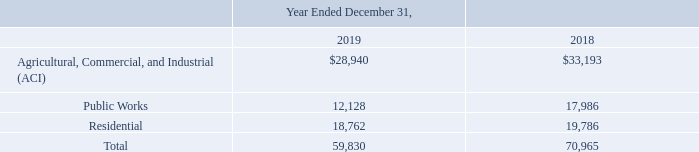3. REVENUE FROM CONTRACTS WITH CUSTOMERS
Revenues and related costs on construction contracts are recognized as the performance obligations are satisfied over time in accordance with ASC 606, Revenue from Contracts with Customers. Under ASC 606, revenue and associated profit, will be recognized as the customer obtains control of the goods and services promised in the contract (i.e., performance obligations). The cost of uninstalled materials or equipment will generally be excluded from the Company’s recognition of profit, unless specifically produced or manufactured for a project, because such costs are not considered to be a measure of progress.
The following table represents a disaggregation of revenue by customer type from contracts with customers for the years ended December 31, 2019 and 2018:
How are revenue and associated profit recognised under ASC 606? Recognized as the customer obtains control of the goods and services promised in the contract (i.e., performance obligations). What is the total revenue in 2019? 59,830. What is the revenue from Residential in 2018? 19,786. What is the percentage change in the revenue from agricultural, commercial and industrial group from 2018 to 2019?
Answer scale should be: percent. (28,940-33,193)/33,193
Answer: -12.81. What is the percentage change in the revenue from public works from 2018 to 2019?
Answer scale should be: percent. (12,128-17,986)/17,986
Answer: -32.57. What is the percent of total revenue from residential in the total revenue for the year ended December 31, 2019?
Answer scale should be: percent. 18,762/59,830
Answer: 31.36. In which year is the revenue from Agricultural, Commercial, and Industrial (ACI) higher? Find the year with the higher revenue from Agricultural, Commercial, and Industrial (ACI)
Answer: 2018. In which year is the revenue from Public Works higher? Find the year with the higher revenue from public works
Answer: 2018. 